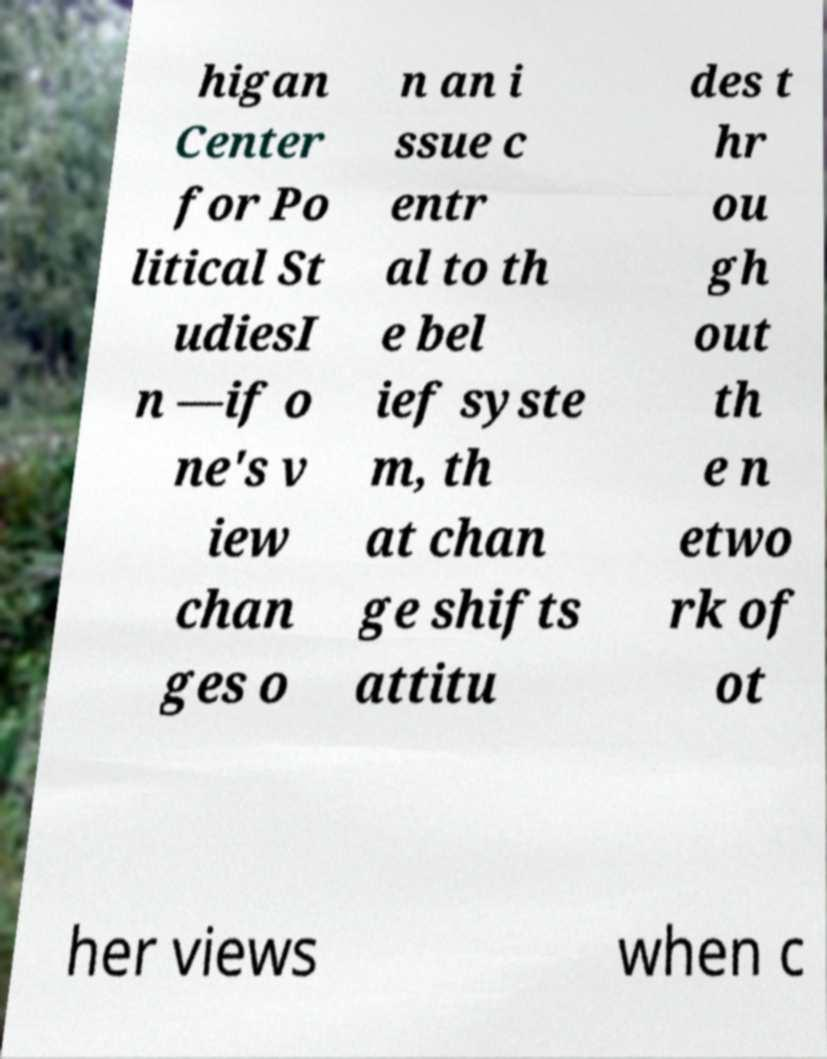Can you read and provide the text displayed in the image?This photo seems to have some interesting text. Can you extract and type it out for me? higan Center for Po litical St udiesI n —if o ne's v iew chan ges o n an i ssue c entr al to th e bel ief syste m, th at chan ge shifts attitu des t hr ou gh out th e n etwo rk of ot her views when c 